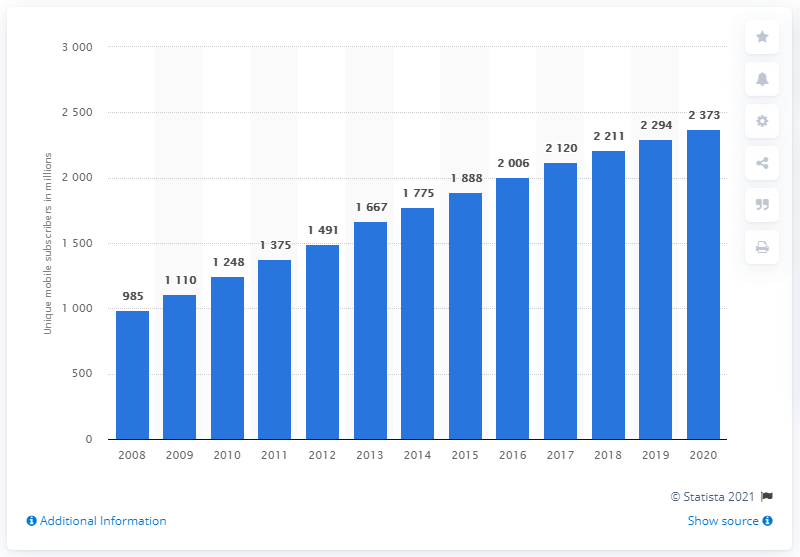Indicate a few pertinent items in this graphic. The number of unique mobile subscribers in the Asia Pacific region is expected to surpass 4 billion by 2019, according to forecasts. 